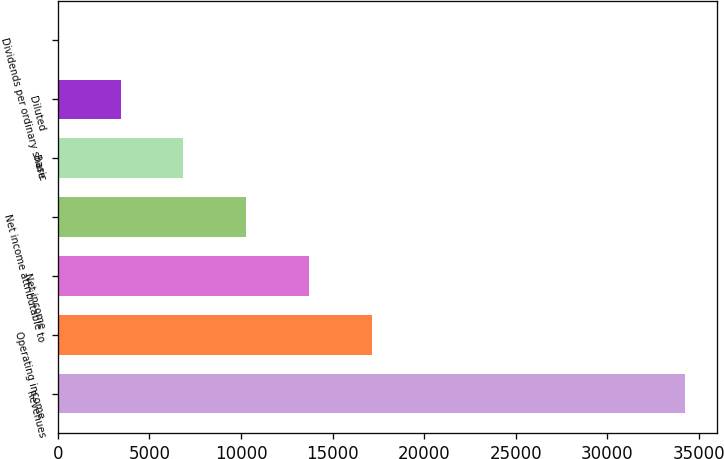Convert chart. <chart><loc_0><loc_0><loc_500><loc_500><bar_chart><fcel>Revenues<fcel>Operating income<fcel>Net income<fcel>Net income attributable to<fcel>Basic<fcel>Diluted<fcel>Dividends per ordinary share<nl><fcel>34254<fcel>17128.1<fcel>13702.9<fcel>10277.7<fcel>6852.56<fcel>3427.38<fcel>2.2<nl></chart> 